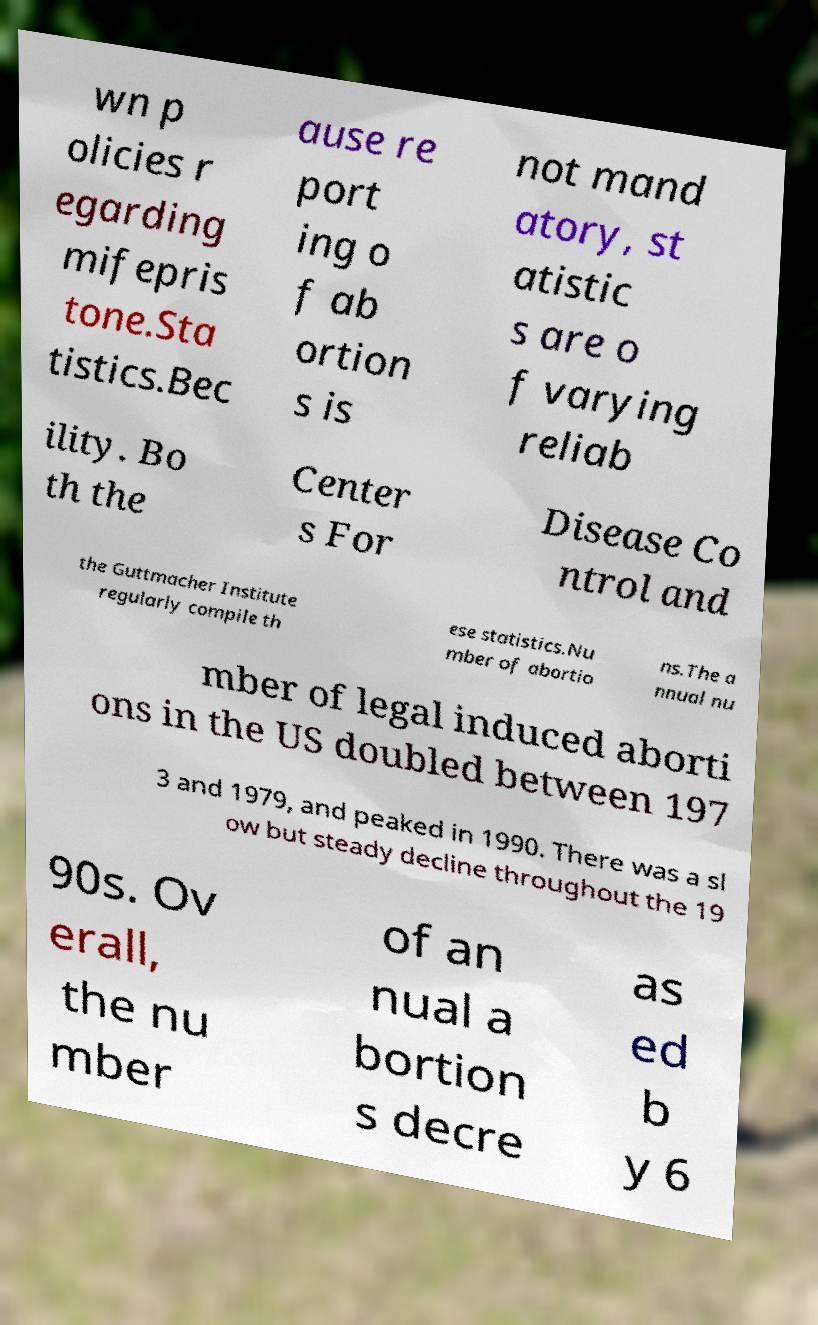Please read and relay the text visible in this image. What does it say? wn p olicies r egarding mifepris tone.Sta tistics.Bec ause re port ing o f ab ortion s is not mand atory, st atistic s are o f varying reliab ility. Bo th the Center s For Disease Co ntrol and the Guttmacher Institute regularly compile th ese statistics.Nu mber of abortio ns.The a nnual nu mber of legal induced aborti ons in the US doubled between 197 3 and 1979, and peaked in 1990. There was a sl ow but steady decline throughout the 19 90s. Ov erall, the nu mber of an nual a bortion s decre as ed b y 6 